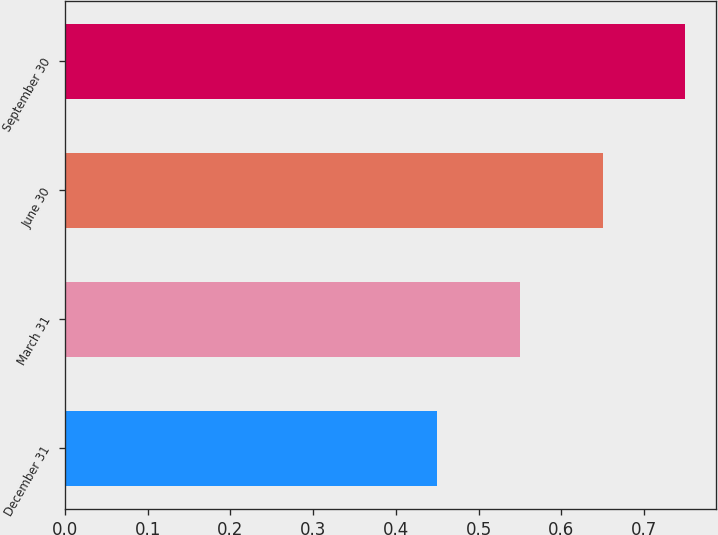Convert chart to OTSL. <chart><loc_0><loc_0><loc_500><loc_500><bar_chart><fcel>December 31<fcel>March 31<fcel>June 30<fcel>September 30<nl><fcel>0.45<fcel>0.55<fcel>0.65<fcel>0.75<nl></chart> 